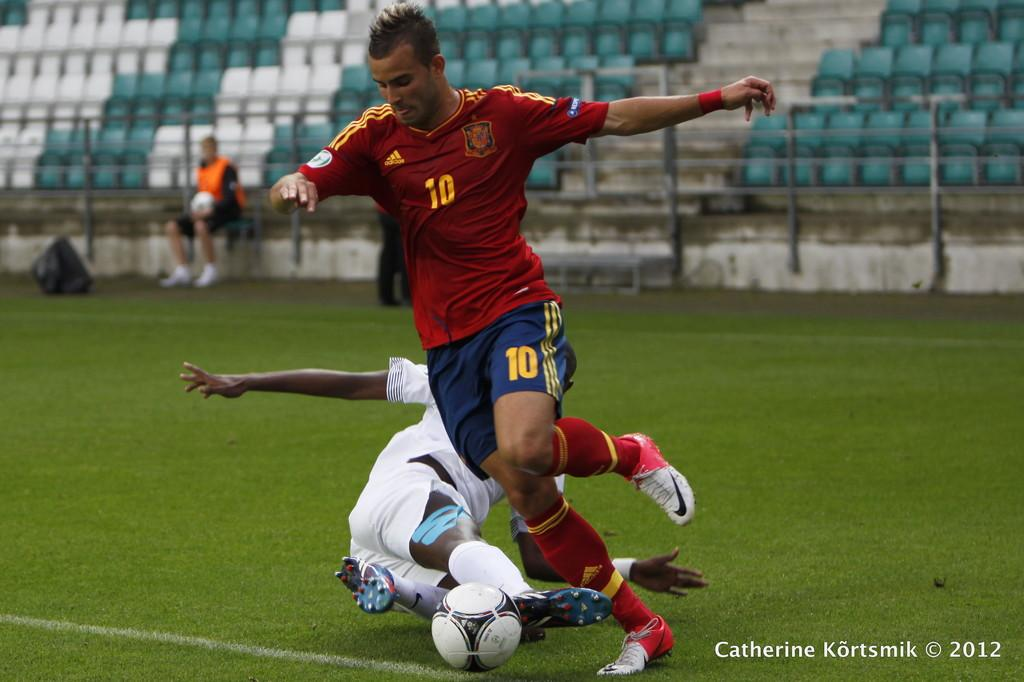<image>
Offer a succinct explanation of the picture presented. Number ten has taken control of the soccer ball. 